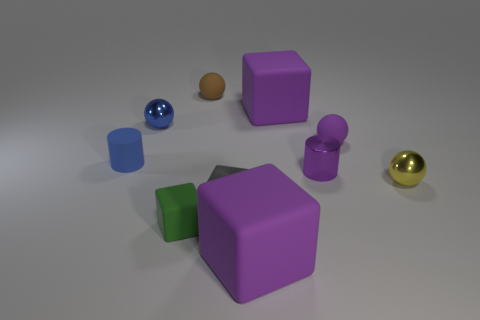Subtract all yellow balls. Subtract all red cylinders. How many balls are left? 3 Subtract all yellow spheres. How many cyan blocks are left? 0 Add 2 big reds. How many blues exist? 0 Subtract all purple metal things. Subtract all big rubber things. How many objects are left? 7 Add 7 tiny rubber balls. How many tiny rubber balls are left? 9 Add 1 big purple rubber things. How many big purple rubber things exist? 3 Subtract all brown spheres. How many spheres are left? 3 Subtract all green rubber cubes. How many cubes are left? 3 Subtract 0 cyan cylinders. How many objects are left? 10 Subtract all cubes. How many objects are left? 6 